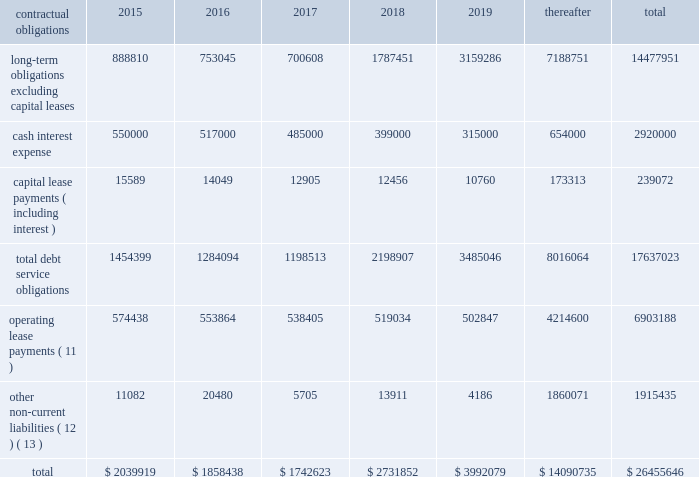
( 1 ) represents anticipated repayment date ; final legal maturity date is march 15 , 2043 .
( 2 ) represents anticipated repayment date ; final legal maturity date is march 15 , 2048 .
( 3 ) in connection with our acquisition of mipt on october 1 , 2013 , we assumed approximately $ 1.49 billion aggregate principal amount of secured notes , $ 250.0 million of which we repaid in august 2014 .
The gtp notes have anticipated repayment dates beginning june 15 , 2016 .
( 4 ) assumed in connection with our acquisition of br towers and denominated in brl .
The br towers debenture amortizes through october 2023 .
The br towers credit facility amortizes through january 15 , ( 5 ) assumed by us in connection with the unison acquisition , and have anticipated repayment dates of april 15 , 2017 , april 15 , 2020 and april 15 , 2020 , respectively , and a final maturity date of april 15 , 2040 .
( 6 ) denominated in mxn .
( 7 ) denominated in zar and amortizes through march 31 , 2020 .
( 8 ) denominated in cop and amortizes through april 24 , 2021 .
( 9 ) reflects balances owed to our joint venture partners in ghana and uganda .
The ghana loan is denominated in ghs and the uganda loan is denominated in usd .
( 10 ) on february 11 , 2015 , we redeemed all of the outstanding 4.625% ( 4.625 % ) notes in accordance with the terms thereof .
( 11 ) includes payments under non-cancellable initial terms , as well as payments for certain renewal periods at our option , which we expect to renew because failure to renew could result in a loss of the applicable communications sites and related revenues from tenant leases .
( 12 ) primarily represents our asset retirement obligations and excludes certain other non-current liabilities included in our consolidated balance sheet , primarily our straight-line rent liability for which cash payments are included in operating lease payments and unearned revenue that is not payable in cash .
( 13 ) excludes $ 26.6 million of liabilities for unrecognized tax positions and $ 24.9 million of accrued income tax related interest and penalties included in our consolidated balance sheet as we are uncertain as to when and if the amounts may be settled .
Settlement of such amounts could require the use of cash flows generated from operations .
We expect the unrecognized tax benefits to change over the next 12 months if certain tax matters ultimately settle with the applicable taxing jurisdiction during this timeframe .
However , based on the status of these items and the amount of uncertainty associated with the outcome and timing of audit settlements , we are currently unable to estimate the impact of the amount of such changes , if any , to previously recorded uncertain tax positions .
Off-balance sheet arrangements .
We have no material off-balance sheet arrangements as defined in item 303 ( a ) ( 4 ) ( ii ) of sec regulation s-k .
Interest rate swap agreements .
We have entered into interest rate swap agreements to manage our exposure to variability in interest rates on debt in colombia and south africa .
All of our interest rate swap agreements have been designated as cash flow hedges and have an aggregate notional amount of $ 79.9 million , interest rates ranging from 5.74% ( 5.74 % ) to 7.83% ( 7.83 % ) and expiration dates through april 2021 .
In february 2014 , we repaid the costa rica loan and subsequently terminated the associated interest rate swap agreements .
Additionally , in connection with entering into the colombian credit facility in october 2014 , we terminated our pre-existing interest rate .
Assuming a midpoint interest rate in the range , what would be the annual interest expense on interest rate swap agreements based on the notional amounts , in millions? 
Computations: ((((5.74 + 7.83) / 2) / 100) * 79.9)
Answer: 5.42122. 